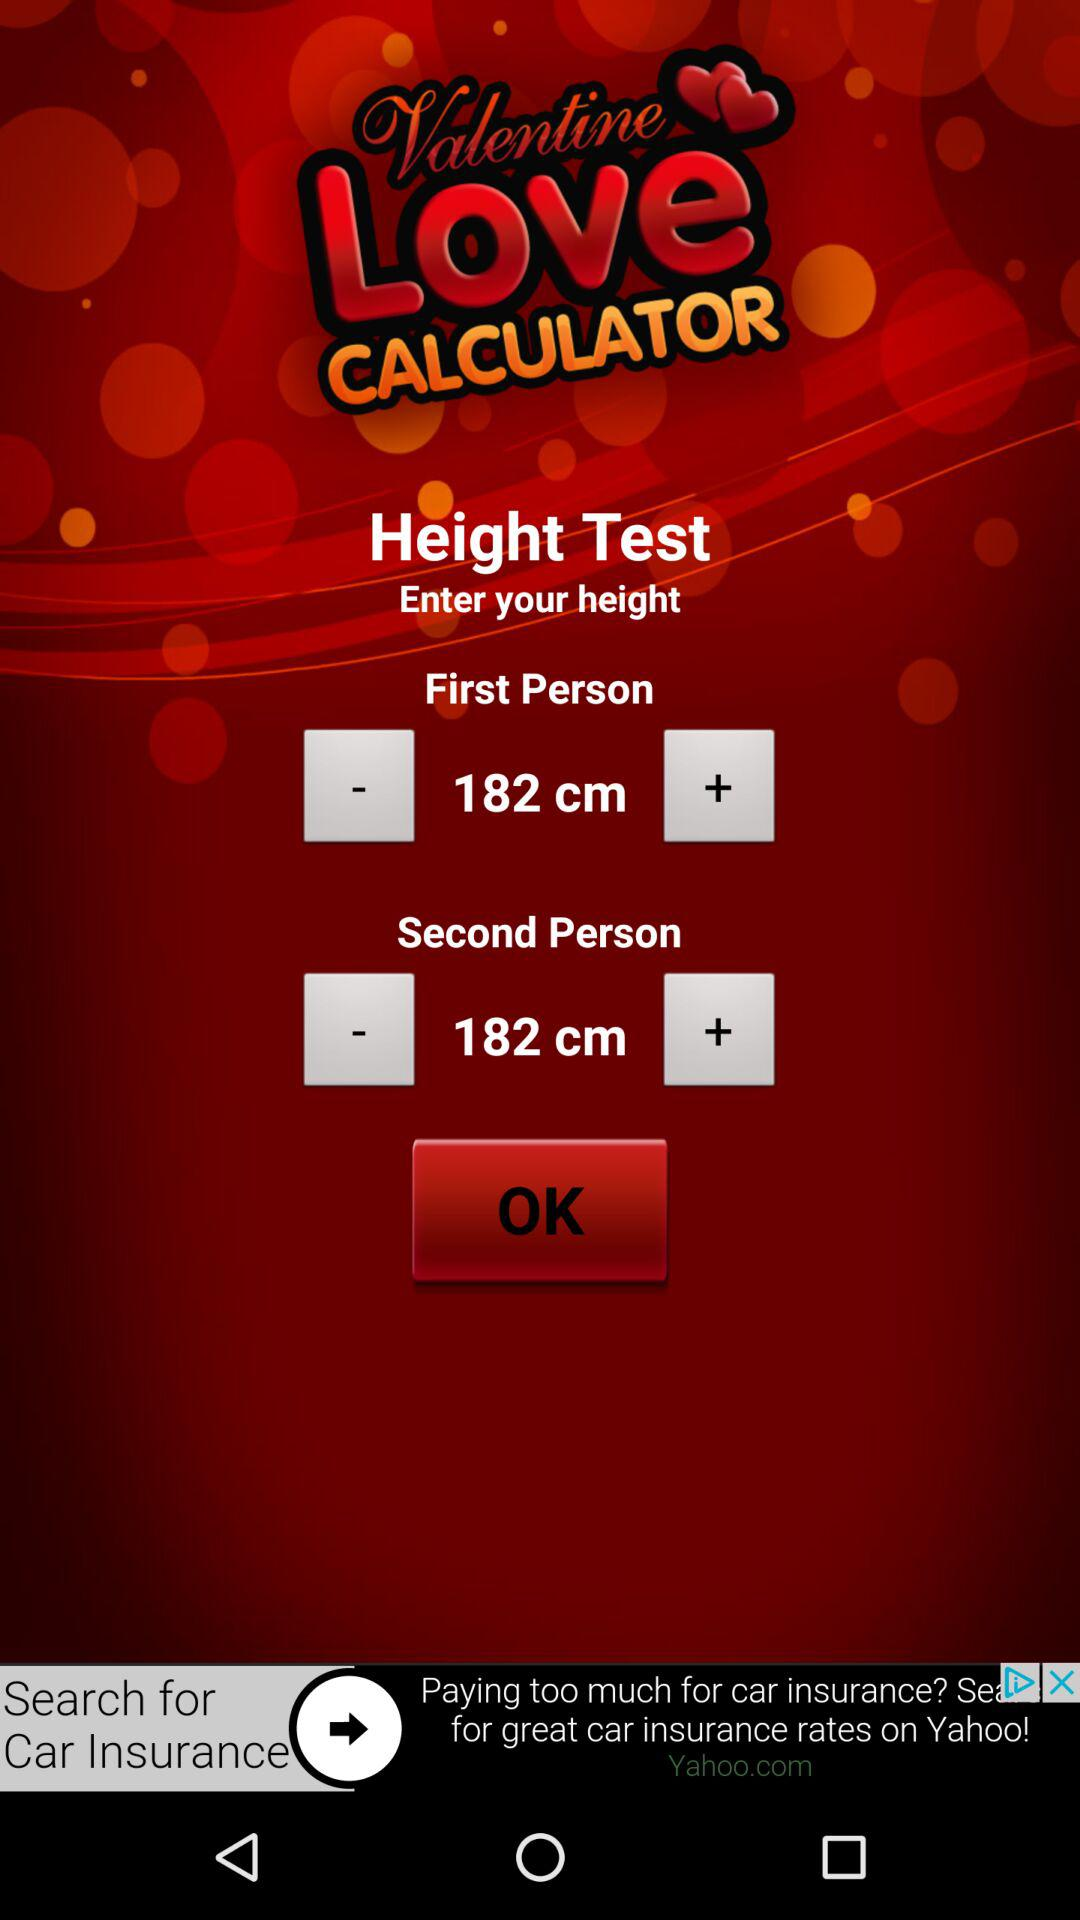What is the second person's height? The second person's height is 182 cm. 